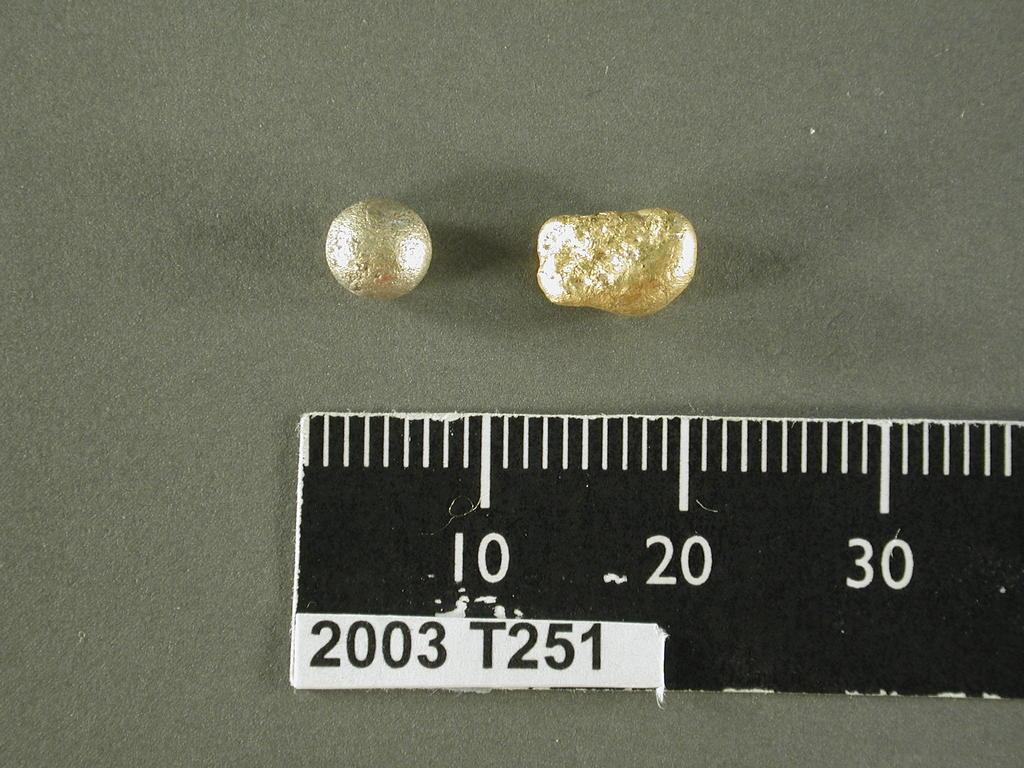<image>
Share a concise interpretation of the image provided. Two small objects sit above a ruler with the label 2003 T251. 